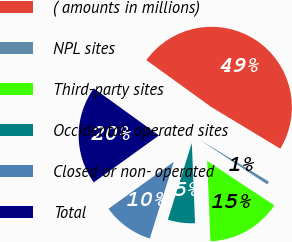Convert chart to OTSL. <chart><loc_0><loc_0><loc_500><loc_500><pie_chart><fcel>( amounts in millions)<fcel>NPL sites<fcel>Third-party sites<fcel>Occidental- operated sites<fcel>Closed or non- operated<fcel>Total<nl><fcel>48.7%<fcel>0.65%<fcel>15.07%<fcel>5.46%<fcel>10.26%<fcel>19.87%<nl></chart> 